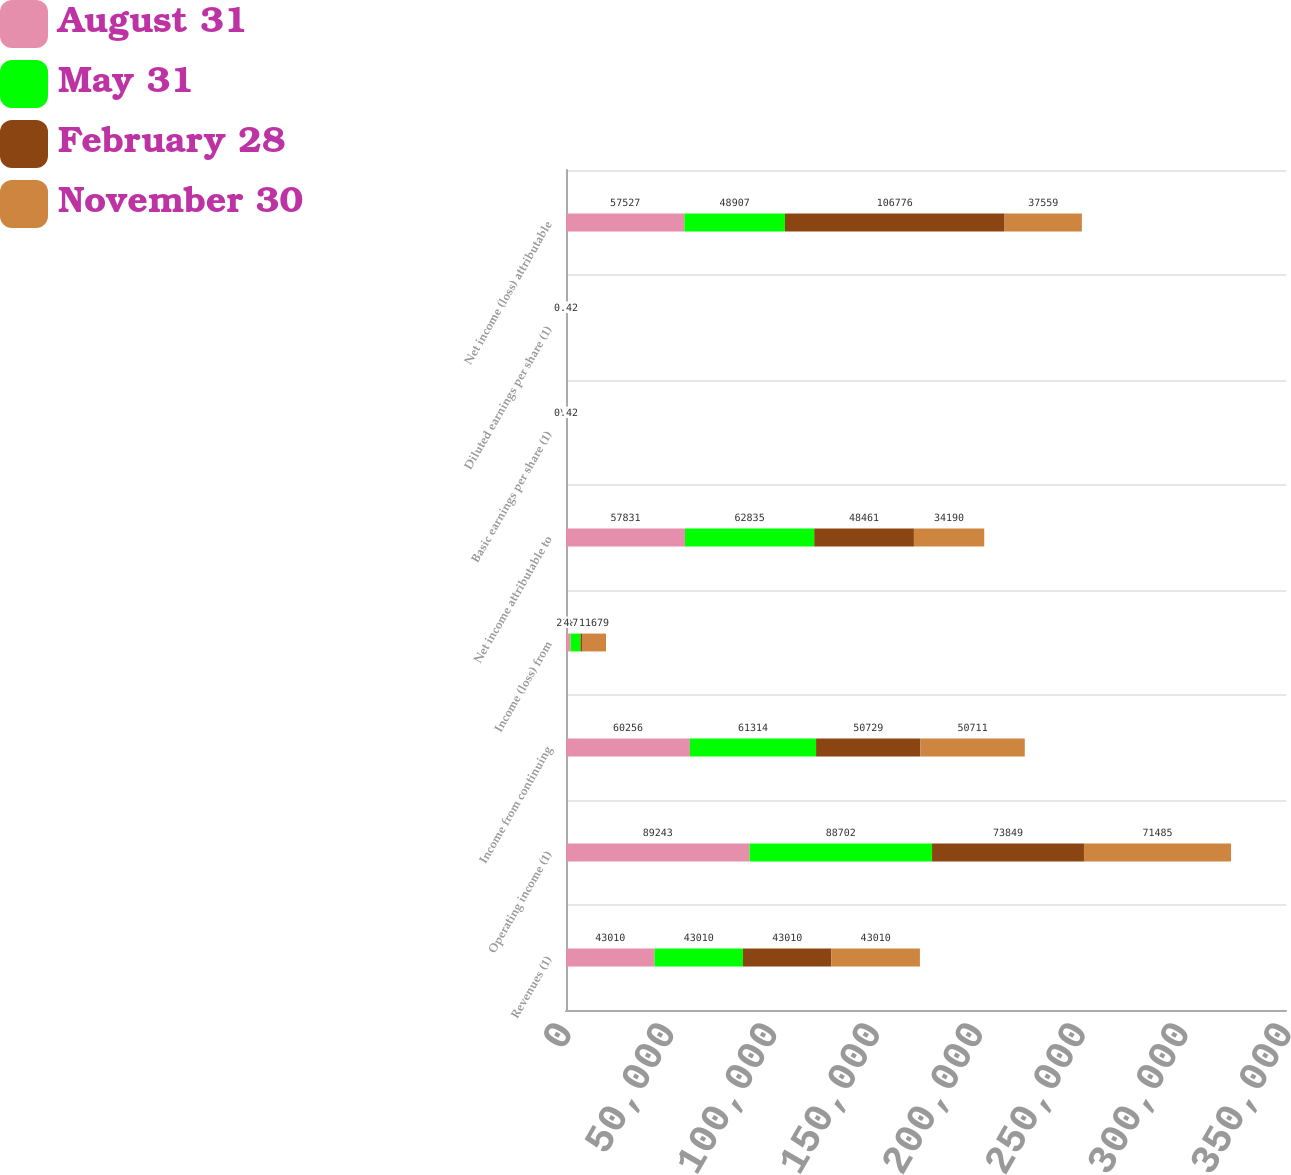Convert chart to OTSL. <chart><loc_0><loc_0><loc_500><loc_500><stacked_bar_chart><ecel><fcel>Revenues (1)<fcel>Operating income (1)<fcel>Income from continuing<fcel>Income (loss) from<fcel>Net income attributable to<fcel>Basic earnings per share (1)<fcel>Diluted earnings per share (1)<fcel>Net income (loss) attributable<nl><fcel>August 31<fcel>43010<fcel>89243<fcel>60256<fcel>2188<fcel>57831<fcel>0.72<fcel>0.71<fcel>57527<nl><fcel>May 31<fcel>43010<fcel>88702<fcel>61314<fcel>4868<fcel>62835<fcel>0.77<fcel>0.76<fcel>48907<nl><fcel>February 28<fcel>43010<fcel>73849<fcel>50729<fcel>722<fcel>48461<fcel>0.6<fcel>0.59<fcel>106776<nl><fcel>November 30<fcel>43010<fcel>71485<fcel>50711<fcel>11679<fcel>34190<fcel>0.42<fcel>0.42<fcel>37559<nl></chart> 